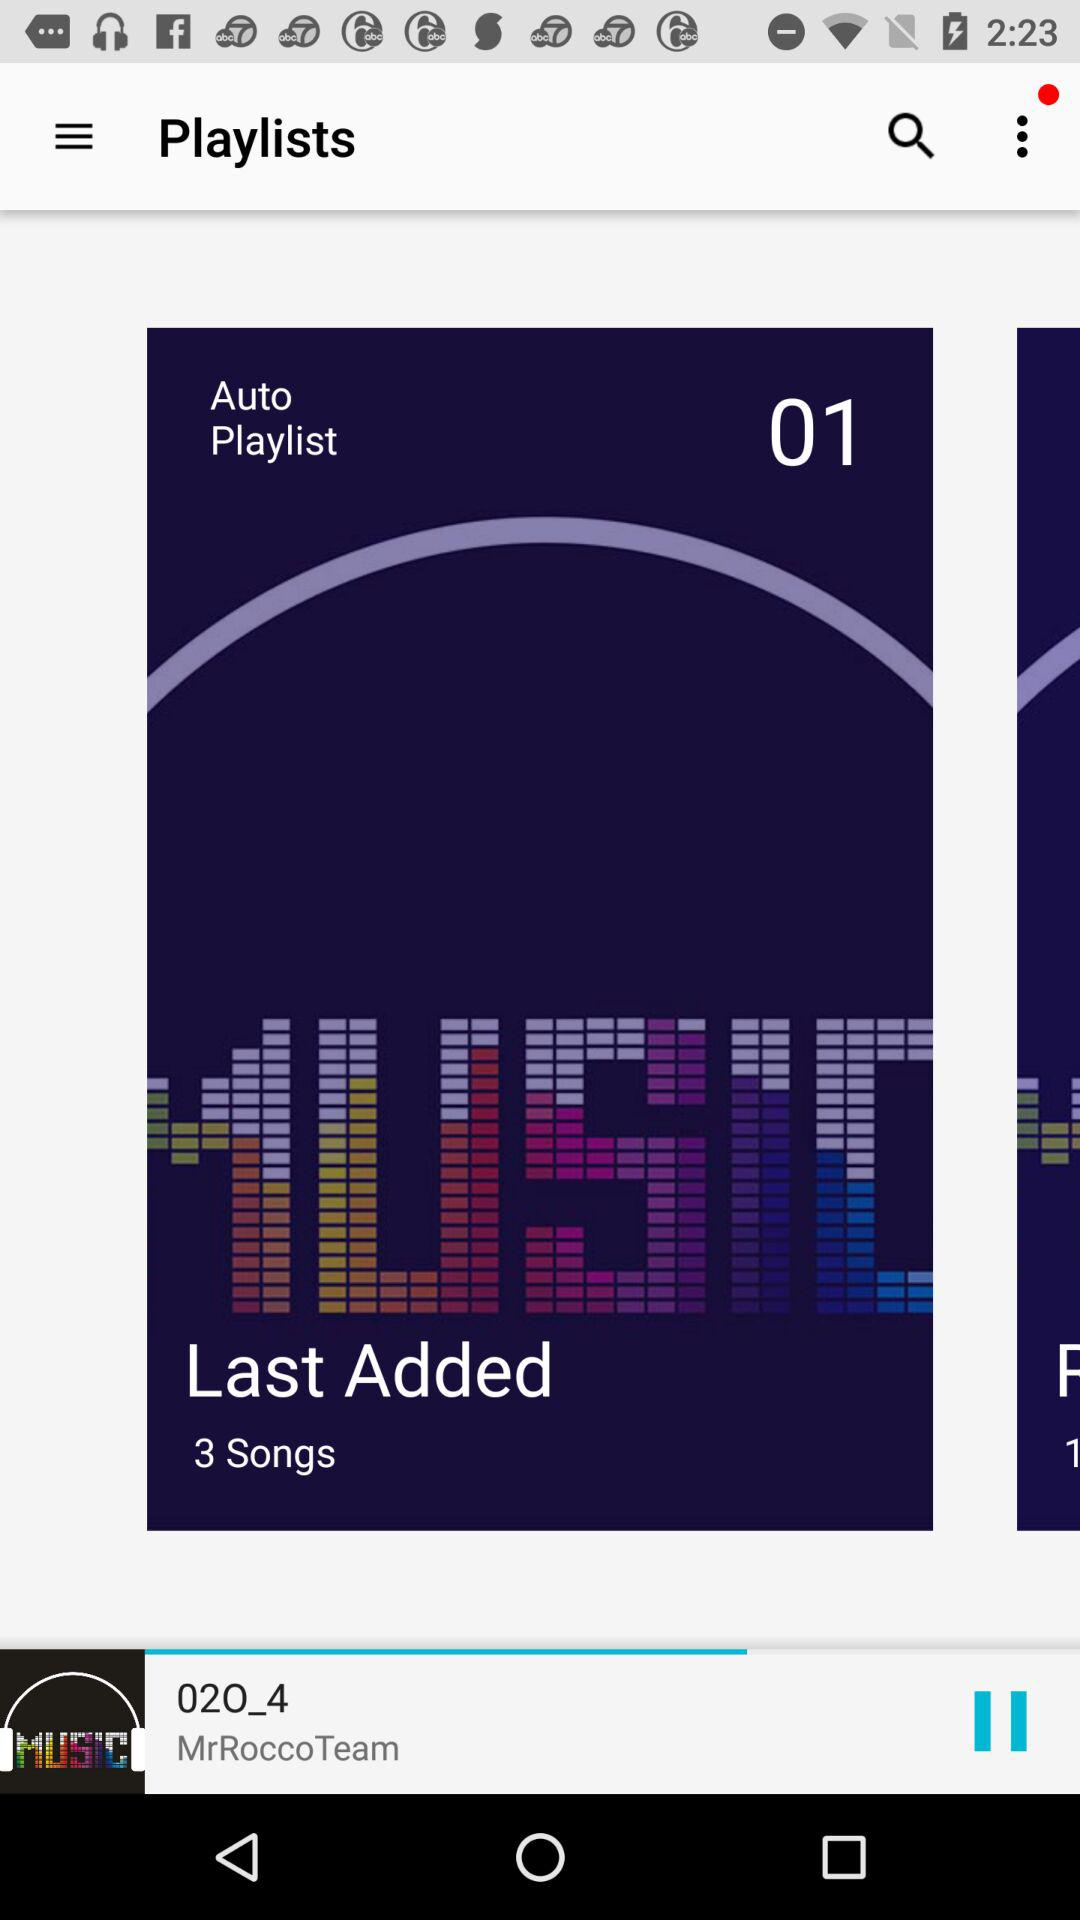How many songs were last added? There were 3 songs last added. 